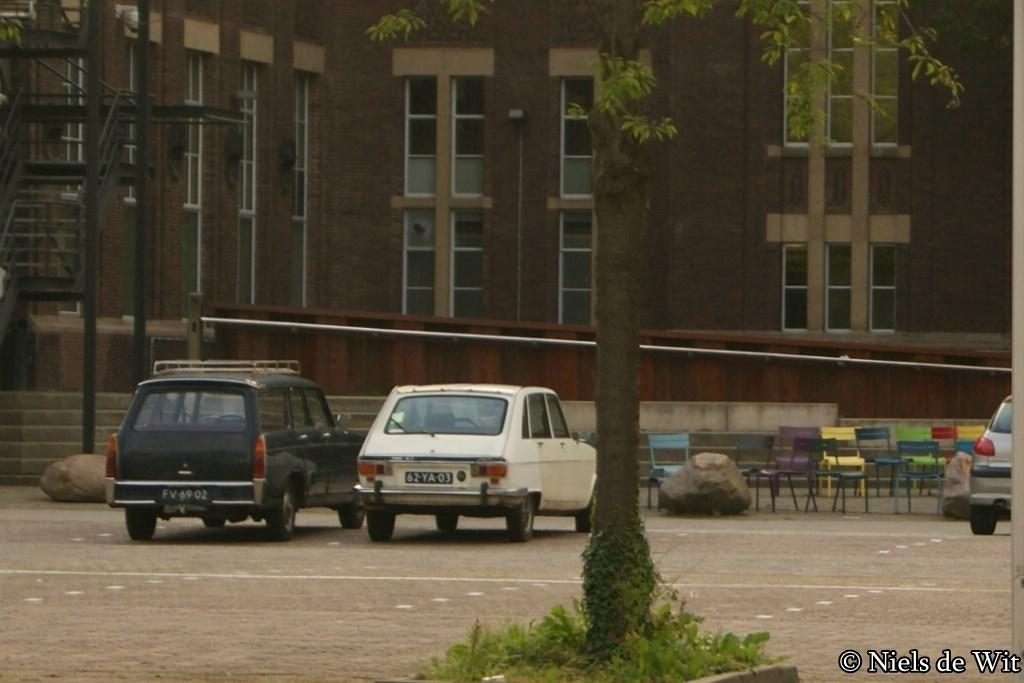What type of vehicles can be seen in the image? There are cars in the image. What type of furniture is present in the image? There are chairs in the image. What type of natural element is visible in the image? There is a tree in the image. What type of man-made structure is visible in the image? There is a building in the image. What architectural feature can be seen on the building? There are windows on the building. How many boys are playing in the office in the image? There is no mention of boys or an office in the image. The image features cars, chairs, a tree, and a building with windows. 